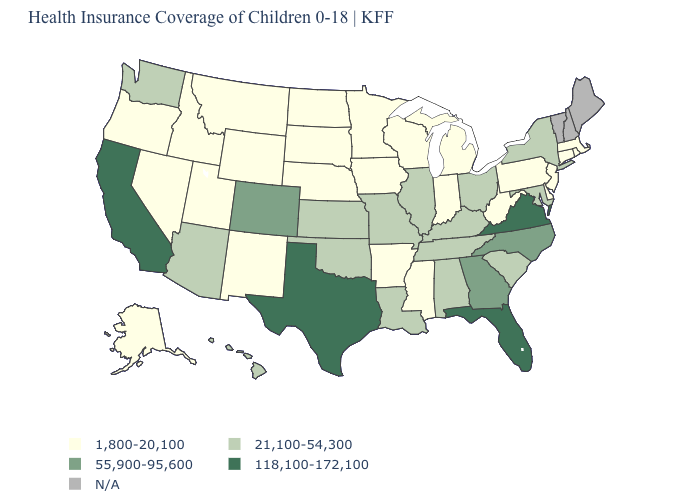Name the states that have a value in the range 55,900-95,600?
Give a very brief answer. Colorado, Georgia, North Carolina. What is the value of Colorado?
Concise answer only. 55,900-95,600. What is the value of Maine?
Quick response, please. N/A. Name the states that have a value in the range 21,100-54,300?
Be succinct. Alabama, Arizona, Hawaii, Illinois, Kansas, Kentucky, Louisiana, Maryland, Missouri, New York, Ohio, Oklahoma, South Carolina, Tennessee, Washington. What is the highest value in the Northeast ?
Be succinct. 21,100-54,300. Does Massachusetts have the lowest value in the Northeast?
Keep it brief. Yes. Does Tennessee have the lowest value in the USA?
Quick response, please. No. Among the states that border Connecticut , does Rhode Island have the highest value?
Short answer required. No. Name the states that have a value in the range 118,100-172,100?
Short answer required. California, Florida, Texas, Virginia. Does the first symbol in the legend represent the smallest category?
Quick response, please. Yes. Among the states that border Utah , does Colorado have the lowest value?
Short answer required. No. What is the value of Alabama?
Be succinct. 21,100-54,300. Which states have the lowest value in the West?
Write a very short answer. Alaska, Idaho, Montana, Nevada, New Mexico, Oregon, Utah, Wyoming. 